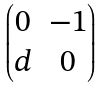Convert formula to latex. <formula><loc_0><loc_0><loc_500><loc_500>\begin{pmatrix} 0 & - 1 \\ d & 0 \end{pmatrix}</formula> 